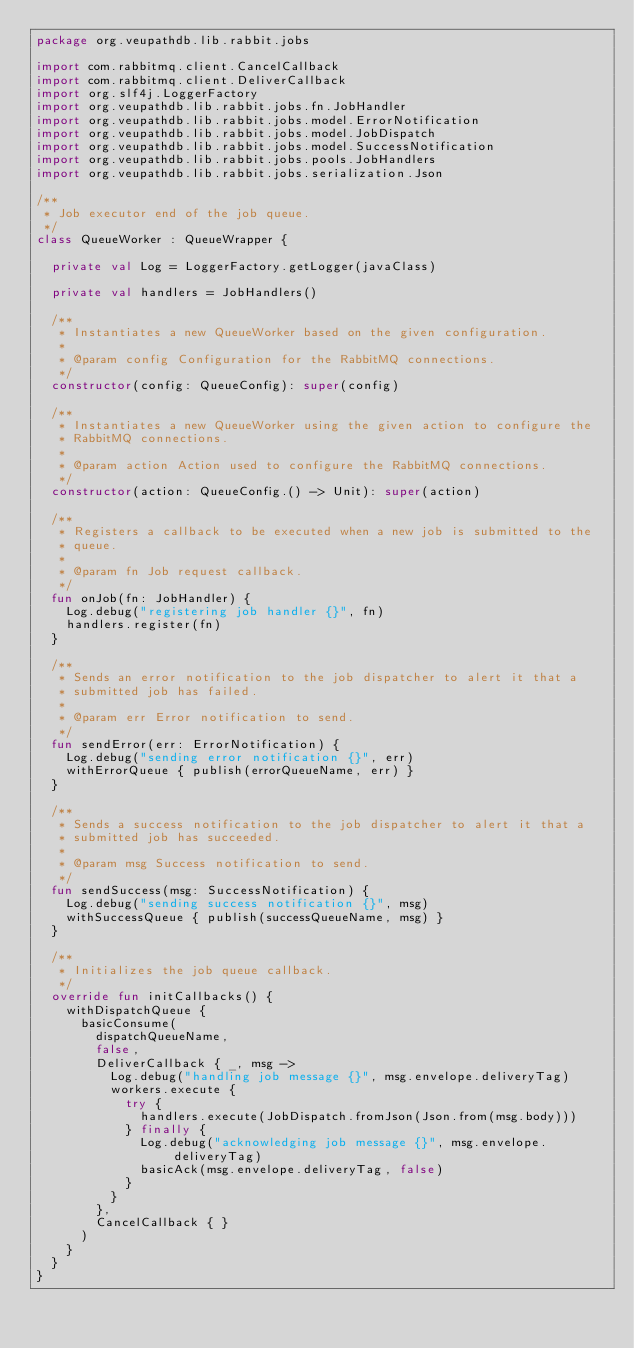Convert code to text. <code><loc_0><loc_0><loc_500><loc_500><_Kotlin_>package org.veupathdb.lib.rabbit.jobs

import com.rabbitmq.client.CancelCallback
import com.rabbitmq.client.DeliverCallback
import org.slf4j.LoggerFactory
import org.veupathdb.lib.rabbit.jobs.fn.JobHandler
import org.veupathdb.lib.rabbit.jobs.model.ErrorNotification
import org.veupathdb.lib.rabbit.jobs.model.JobDispatch
import org.veupathdb.lib.rabbit.jobs.model.SuccessNotification
import org.veupathdb.lib.rabbit.jobs.pools.JobHandlers
import org.veupathdb.lib.rabbit.jobs.serialization.Json

/**
 * Job executor end of the job queue.
 */
class QueueWorker : QueueWrapper {

  private val Log = LoggerFactory.getLogger(javaClass)

  private val handlers = JobHandlers()

  /**
   * Instantiates a new QueueWorker based on the given configuration.
   *
   * @param config Configuration for the RabbitMQ connections.
   */
  constructor(config: QueueConfig): super(config)

  /**
   * Instantiates a new QueueWorker using the given action to configure the
   * RabbitMQ connections.
   *
   * @param action Action used to configure the RabbitMQ connections.
   */
  constructor(action: QueueConfig.() -> Unit): super(action)

  /**
   * Registers a callback to be executed when a new job is submitted to the
   * queue.
   *
   * @param fn Job request callback.
   */
  fun onJob(fn: JobHandler) {
    Log.debug("registering job handler {}", fn)
    handlers.register(fn)
  }

  /**
   * Sends an error notification to the job dispatcher to alert it that a
   * submitted job has failed.
   *
   * @param err Error notification to send.
   */
  fun sendError(err: ErrorNotification) {
    Log.debug("sending error notification {}", err)
    withErrorQueue { publish(errorQueueName, err) }
  }

  /**
   * Sends a success notification to the job dispatcher to alert it that a
   * submitted job has succeeded.
   *
   * @param msg Success notification to send.
   */
  fun sendSuccess(msg: SuccessNotification) {
    Log.debug("sending success notification {}", msg)
    withSuccessQueue { publish(successQueueName, msg) }
  }

  /**
   * Initializes the job queue callback.
   */
  override fun initCallbacks() {
    withDispatchQueue {
      basicConsume(
        dispatchQueueName,
        false,
        DeliverCallback { _, msg ->
          Log.debug("handling job message {}", msg.envelope.deliveryTag)
          workers.execute {
            try {
              handlers.execute(JobDispatch.fromJson(Json.from(msg.body)))
            } finally {
              Log.debug("acknowledging job message {}", msg.envelope.deliveryTag)
              basicAck(msg.envelope.deliveryTag, false)
            }
          }
        },
        CancelCallback { }
      )
    }
  }
}</code> 